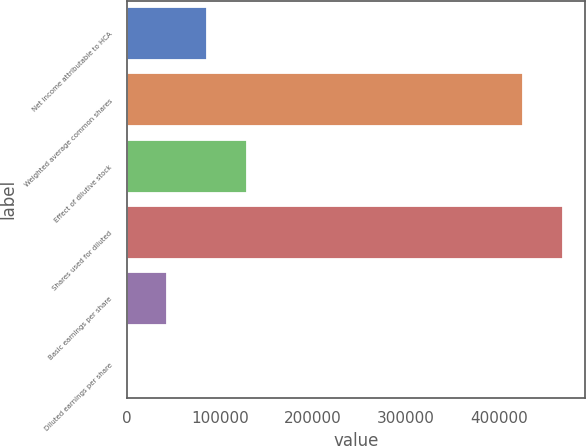<chart> <loc_0><loc_0><loc_500><loc_500><bar_chart><fcel>Net income attributable to HCA<fcel>Weighted average common shares<fcel>Effect of dilutive stock<fcel>Shares used for diluted<fcel>Basic earnings per share<fcel>Diluted earnings per share<nl><fcel>86447.4<fcel>425567<fcel>129670<fcel>468789<fcel>43224.9<fcel>2.44<nl></chart> 